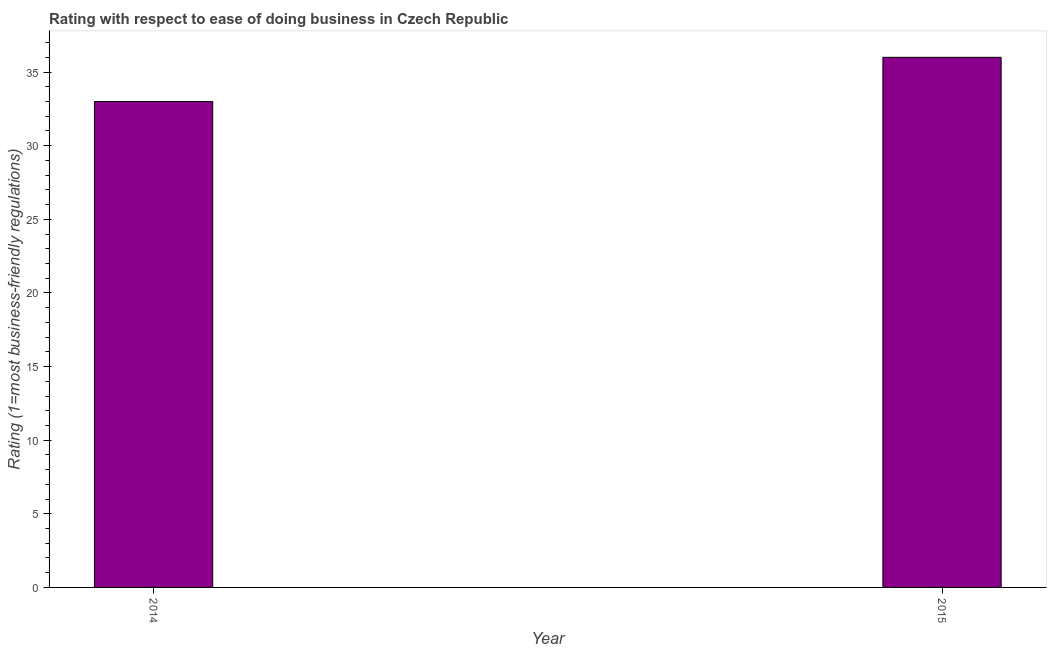Does the graph contain grids?
Offer a terse response. No. What is the title of the graph?
Ensure brevity in your answer.  Rating with respect to ease of doing business in Czech Republic. What is the label or title of the X-axis?
Offer a very short reply. Year. What is the label or title of the Y-axis?
Ensure brevity in your answer.  Rating (1=most business-friendly regulations). Across all years, what is the maximum ease of doing business index?
Keep it short and to the point. 36. Across all years, what is the minimum ease of doing business index?
Provide a succinct answer. 33. In which year was the ease of doing business index maximum?
Keep it short and to the point. 2015. In which year was the ease of doing business index minimum?
Your answer should be compact. 2014. What is the sum of the ease of doing business index?
Provide a succinct answer. 69. What is the median ease of doing business index?
Provide a short and direct response. 34.5. In how many years, is the ease of doing business index greater than 6 ?
Offer a very short reply. 2. What is the ratio of the ease of doing business index in 2014 to that in 2015?
Keep it short and to the point. 0.92. In how many years, is the ease of doing business index greater than the average ease of doing business index taken over all years?
Offer a very short reply. 1. How many bars are there?
Make the answer very short. 2. Are the values on the major ticks of Y-axis written in scientific E-notation?
Offer a very short reply. No. What is the Rating (1=most business-friendly regulations) of 2014?
Offer a very short reply. 33. What is the Rating (1=most business-friendly regulations) of 2015?
Offer a very short reply. 36. What is the ratio of the Rating (1=most business-friendly regulations) in 2014 to that in 2015?
Your response must be concise. 0.92. 